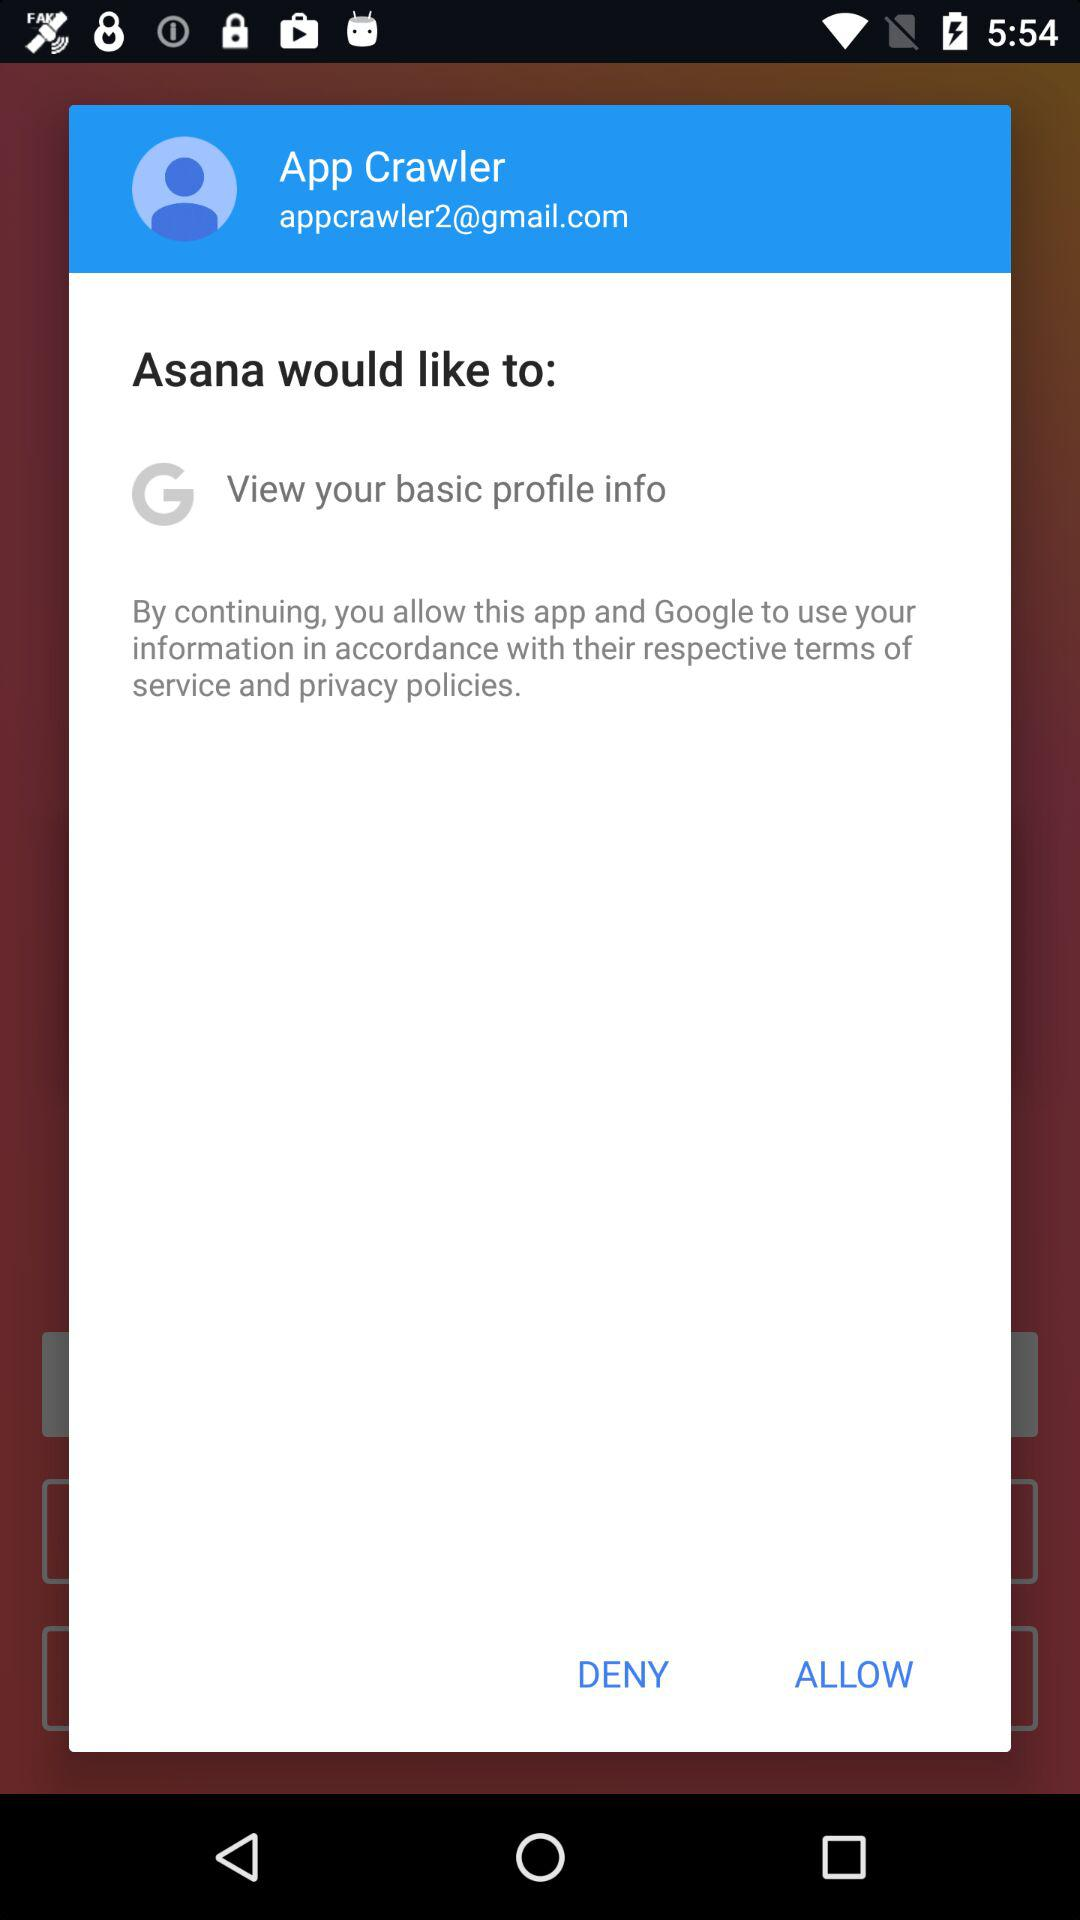What is the user name? The user name is App Crawler. 